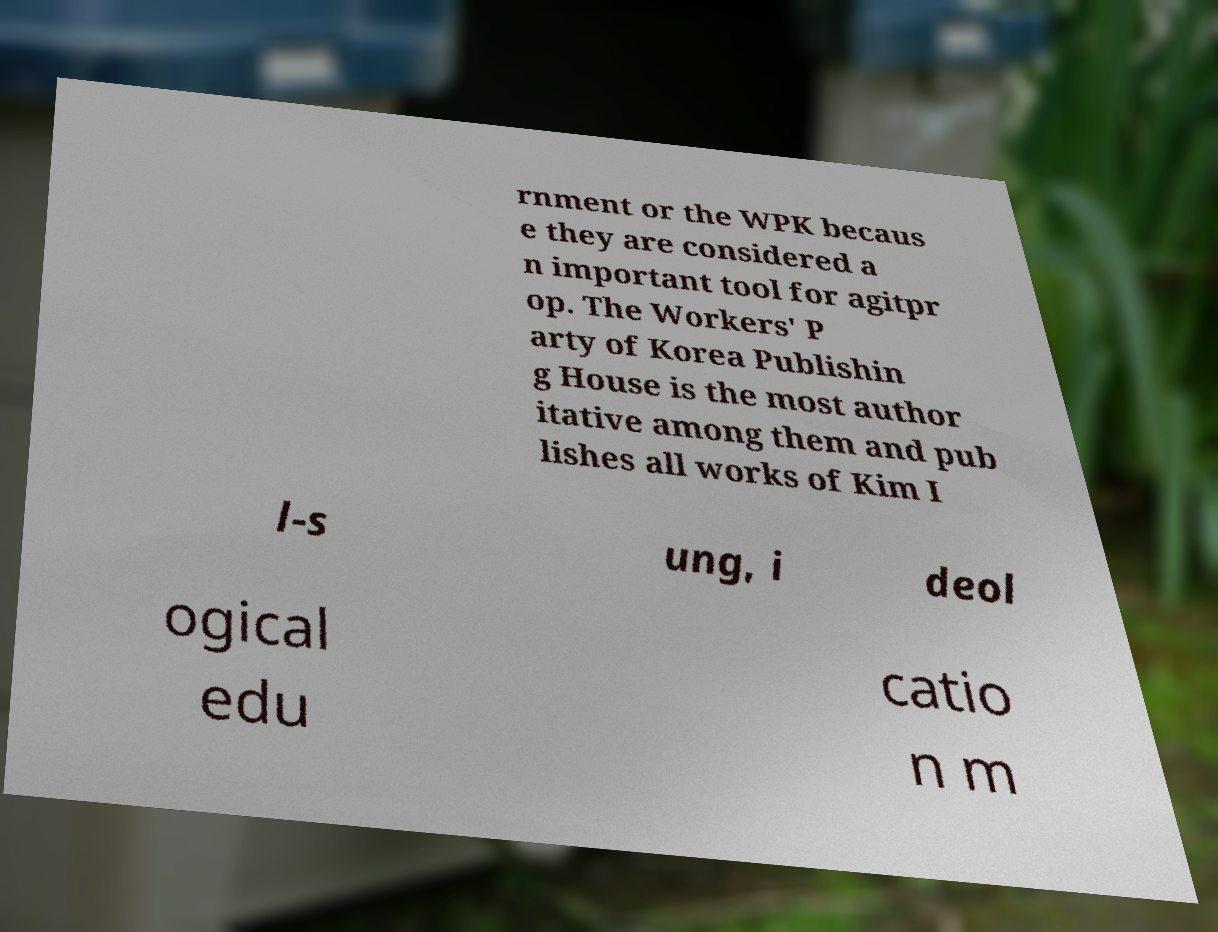I need the written content from this picture converted into text. Can you do that? rnment or the WPK becaus e they are considered a n important tool for agitpr op. The Workers' P arty of Korea Publishin g House is the most author itative among them and pub lishes all works of Kim I l-s ung, i deol ogical edu catio n m 